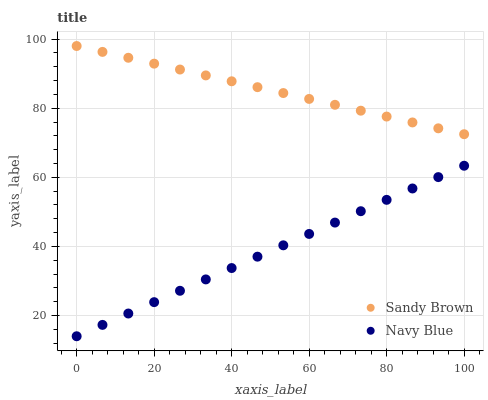Does Navy Blue have the minimum area under the curve?
Answer yes or no. Yes. Does Sandy Brown have the maximum area under the curve?
Answer yes or no. Yes. Does Sandy Brown have the minimum area under the curve?
Answer yes or no. No. Is Sandy Brown the smoothest?
Answer yes or no. Yes. Is Navy Blue the roughest?
Answer yes or no. Yes. Is Sandy Brown the roughest?
Answer yes or no. No. Does Navy Blue have the lowest value?
Answer yes or no. Yes. Does Sandy Brown have the lowest value?
Answer yes or no. No. Does Sandy Brown have the highest value?
Answer yes or no. Yes. Is Navy Blue less than Sandy Brown?
Answer yes or no. Yes. Is Sandy Brown greater than Navy Blue?
Answer yes or no. Yes. Does Navy Blue intersect Sandy Brown?
Answer yes or no. No. 